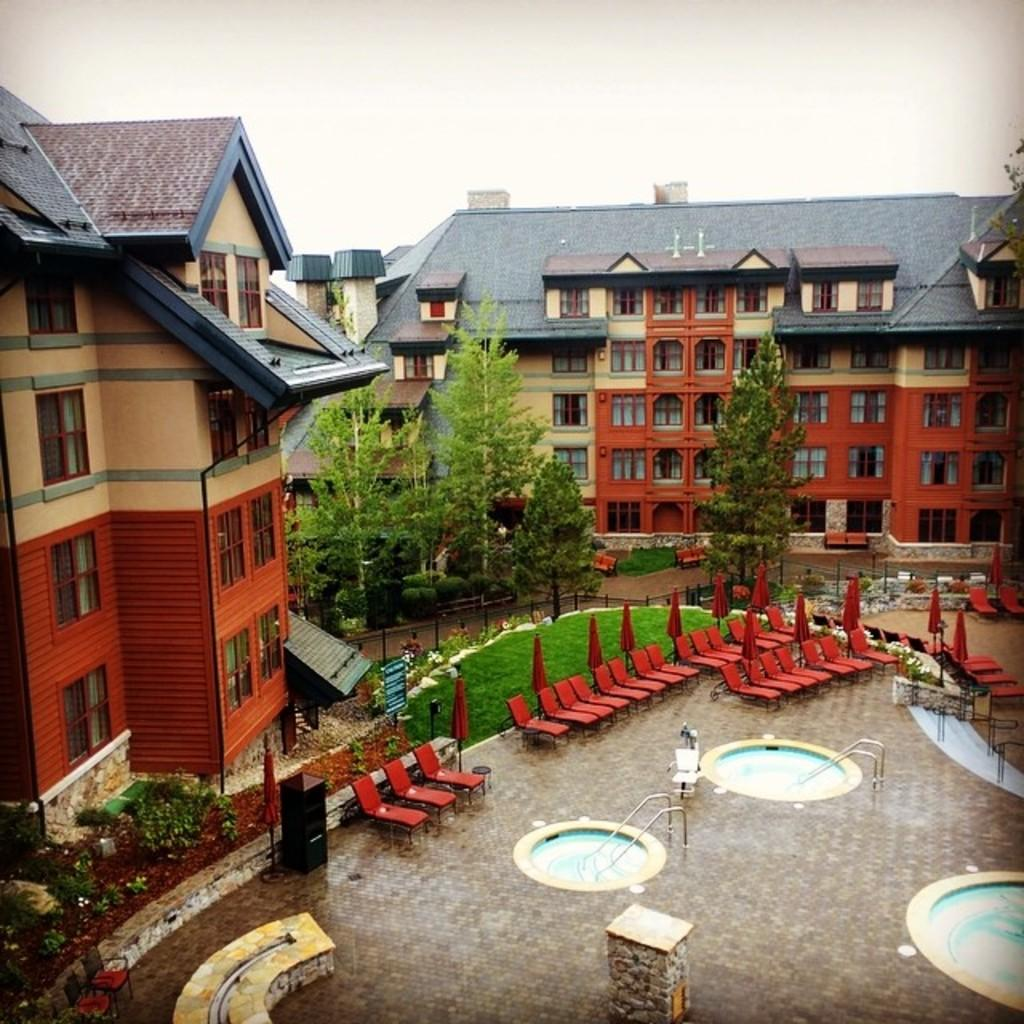What type of structures can be seen in the image? There are buildings in the image. What natural elements are present in the image? There are trees, grass, and plants in the image. What type of seating is available in the image? There are benches and chairs in the image. What type of recreational feature can be seen in the image? There are pools in the image. Are there any fangs visible on the buildings in the image? There are no fangs present in the image; it features buildings, trees, grass, benches, chairs, pools, and plants. Can you see any giants walking around in the image? There are no giants present in the image. Is there an army visible in the image? There is no army present in the image. 